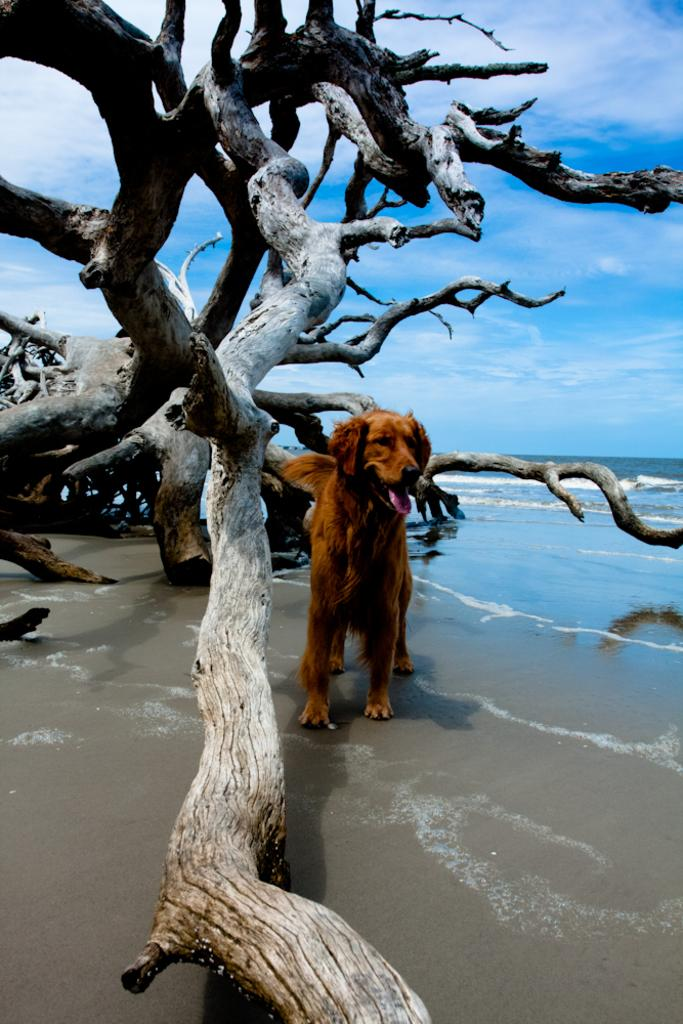What animal can be seen in the image? There is a dog in the image. What surface is the dog standing on? The dog is standing on the sand. How close is the dog to the water? The dog is near the water. What type of vegetation can be seen in the image? There are cut down bare trees in the image. What can be seen in the sky in the background of the image? There are clouds visible in the sky in the background of the image. What type of alarm is the dog using to signal its presence in the image? There is no alarm present in the image; the dog's presence is visually apparent. How many ducks are swimming in the water near the dog in the image? There are no ducks present in the image; it only features a dog standing on the sand near the water. 